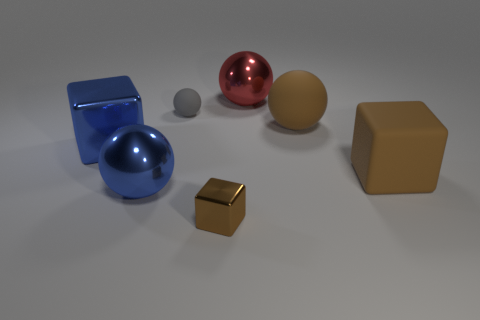Subtract all shiny blocks. How many blocks are left? 1 Add 1 brown matte spheres. How many objects exist? 8 Subtract all gray spheres. How many spheres are left? 3 Subtract all balls. How many objects are left? 3 Add 5 big blue spheres. How many big blue spheres are left? 6 Add 4 big yellow rubber things. How many big yellow rubber things exist? 4 Subtract 0 purple blocks. How many objects are left? 7 Subtract all red cubes. Subtract all yellow balls. How many cubes are left? 3 Subtract all green cubes. How many green spheres are left? 0 Subtract all small cubes. Subtract all red things. How many objects are left? 5 